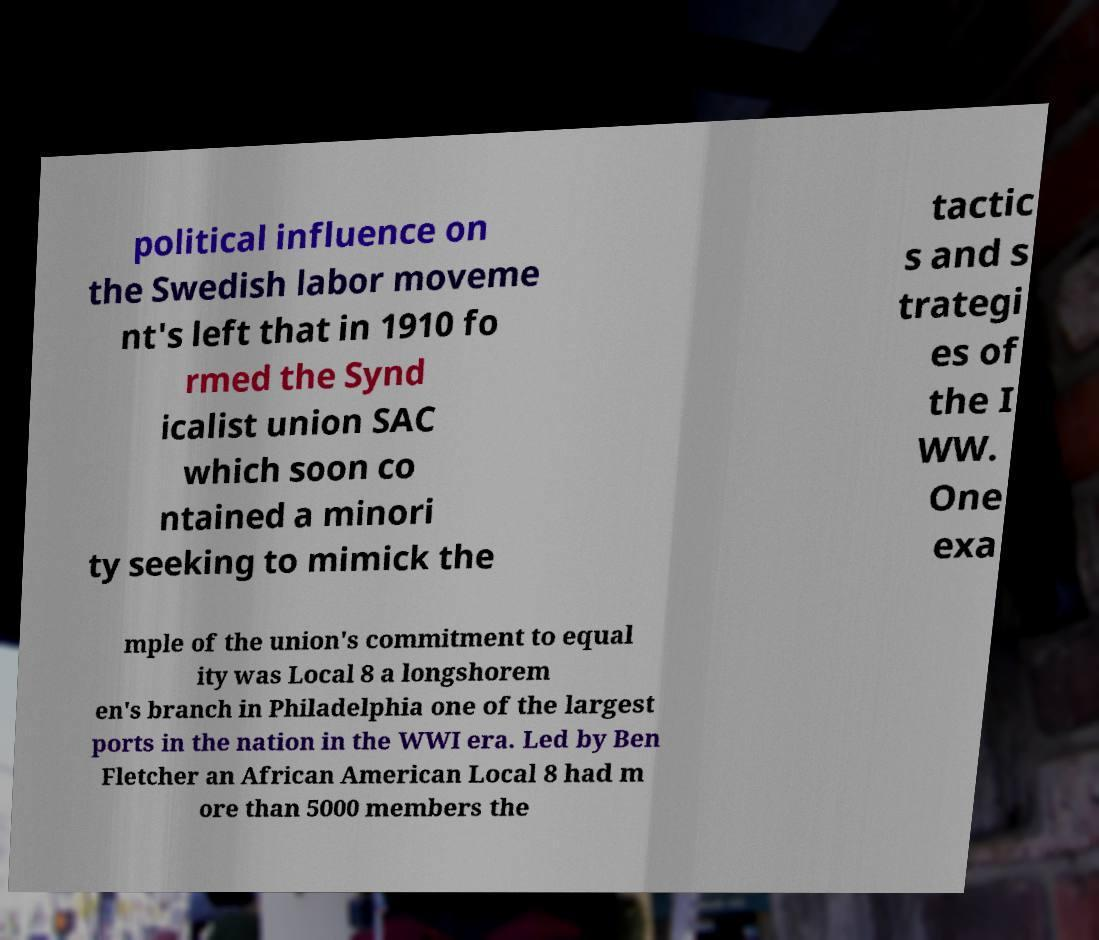Please read and relay the text visible in this image. What does it say? political influence on the Swedish labor moveme nt's left that in 1910 fo rmed the Synd icalist union SAC which soon co ntained a minori ty seeking to mimick the tactic s and s trategi es of the I WW. One exa mple of the union's commitment to equal ity was Local 8 a longshorem en's branch in Philadelphia one of the largest ports in the nation in the WWI era. Led by Ben Fletcher an African American Local 8 had m ore than 5000 members the 